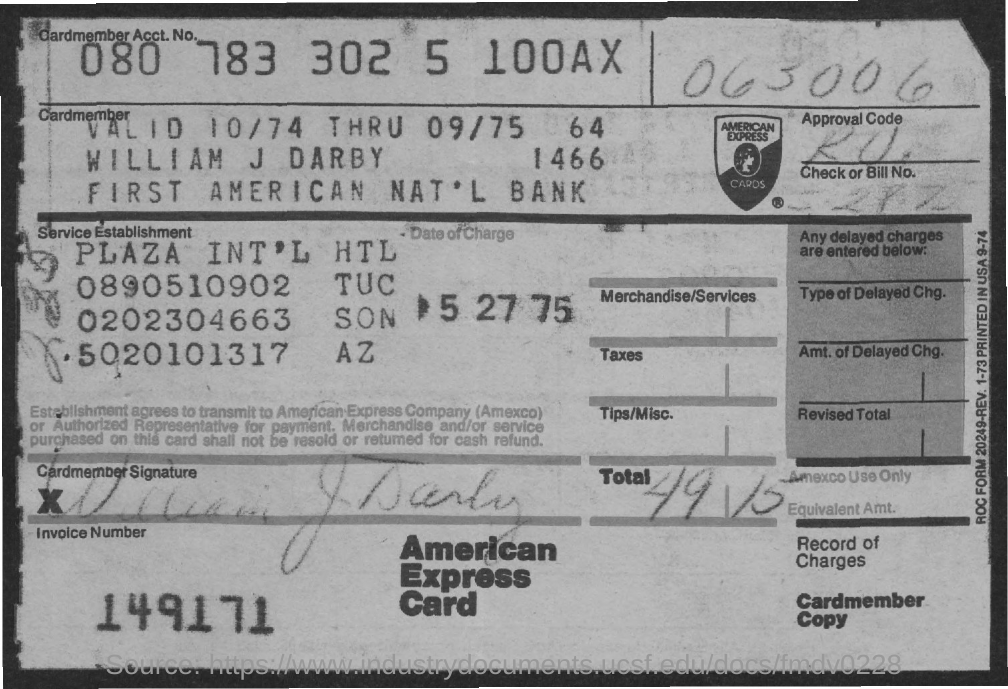What the cardmember acct. no?
Make the answer very short. 080 783 302 5 100AX. What is the card holder name?
Make the answer very short. William J Darby. What is card name?
Provide a short and direct response. American express card. What is invoice number?
Offer a very short reply. 149171. What is the date of change?
Keep it short and to the point. 5-27-75. 